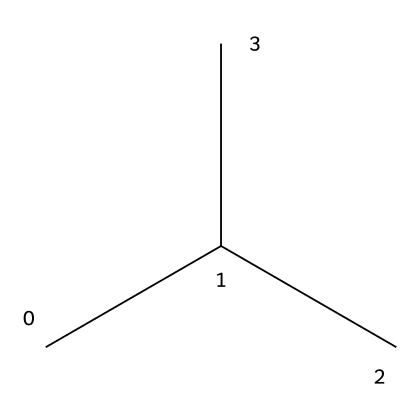What is the name of the chemical represented by the SMILES? The SMILES "CC(C)C" depicts isopropyl, which is an alkyl group commonly found in various types of plastics, including polypropylene.
Answer: isopropyl How many carbon atoms are there in the chemical? The structure "CC(C)C" indicates there are three carbon atoms connected in a branching manner; counting them yields a total of 3.
Answer: 3 What type of bonding is present in this chemical structure? The chemical features single bonds between the carbon atoms, typical of aliphatic hydrocarbons like those found in polymers such as polypropylene.
Answer: single bonds What is the maximum number of hydrogen atoms in this chemical? Each carbon can bond to a maximum of four other atoms. Given the branching structure, the maximum for isopropyl is 8 hydrogen atoms (C3H8).
Answer: 8 What type of plastic is derived from this chemical structure? Isopropyl contributes to the formation of polypropylene, which is a common thermoplastic widely used in various applications, including stadium seating.
Answer: polypropylene What type of functional group is associated with the chemical? The chemical structure has no functional groups as it is a simple hydrocarbon (alkane) with only carbon and hydrogen atoms, typical for many plastics.
Answer: none 